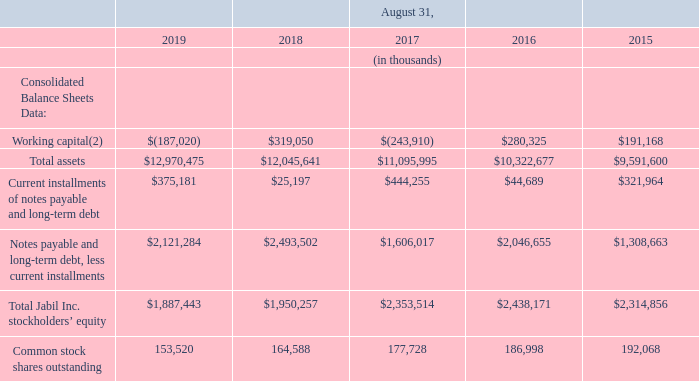Item 6. Selected Financial Data
The following selected data is derived from our Consolidated Financial Statements. This data should be read in conjunction with the Consolidated Financial Statements and notes thereto incorporated into Item 8, “Financial Statements and Supplementary Data” and with Item 7, “Management’s Discussion and Analysis of Financial Condition and Results of Operations.”
(2) Working capital is defined as current assets minus current liabilities.
How does the company define working capital? Current assets minus current liabilities. What were the total assets in 2019?
Answer scale should be: thousand. $12,970,475. What are the years included in the table? 2019, 2018, 2017, 2016, 2015. What was the change in Current installments of notes payable and long-term debt between 2018 and 2019?
Answer scale should be: thousand. $375,181-$25,197
Answer: 349984. How many years did Common stock shares outstanding exceed $160,000 thousand? 2018##2017##2016##2015
Answer: 4. What was the percentage change in Total Jabil Inc. stockholders’ equity between 2018 and 2019?
Answer scale should be: percent. (1,887,443-1,950,257)/1,950,257
Answer: -3.22. 